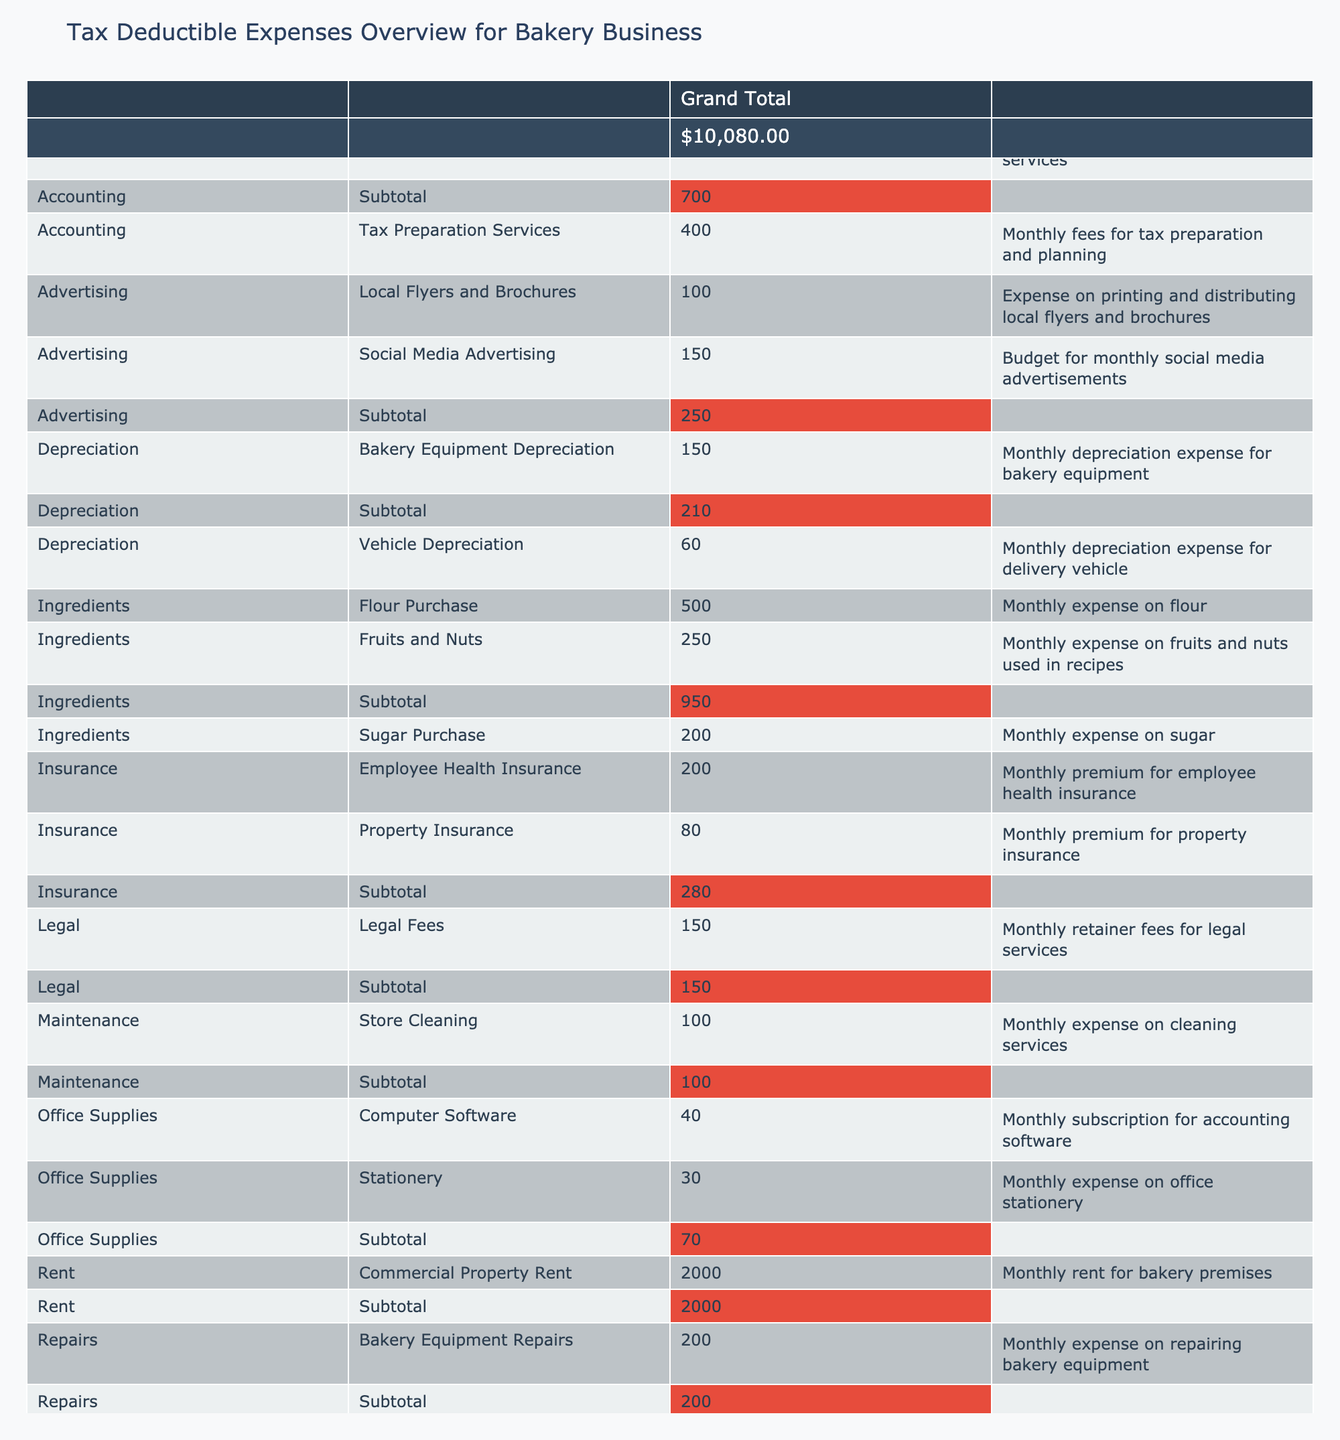What is the total amount spent on Utilities? The utilities expenditures in the table include Electricity Bill ($350), Water Bill ($50), and Gas Bill ($100). Adding these amounts gives a total of $350 + $50 + $100 = $500.
Answer: 500 What is the expense for Ingredients in total? The total expenses for Ingredients include Flour Purchase ($500), Sugar Purchase ($200), and Fruits and Nuts ($250). Summing these amounts: $500 + $200 + $250 gives a total of $950.
Answer: 950 Is the total amount spent on Salaries greater than the total amount spent on Insurance? The total Salaries expenses amount to Baker Salaries ($3000) plus Administrative Salaries ($1500), which equals $4500. The total Insurance expenses are Property Insurance ($80) plus Employee Health Insurance ($200), totaling $280. Since $4500 is greater than $280, the statement is true.
Answer: Yes What is the difference between the total amount spent on Advertising and the total amount dedicated to Repairs? The total Advertising expenses consist of Social Media Advertising ($150) and Local Flyers and Brochures ($100), totaling $250. The Repairs expense is solely Bakery Equipment Repairs ($200). The difference is $250 - $200, which equals $50.
Answer: 50 How much is spent on Depreciation for Bakery Equipment relative to Depreciation for Vehicle? The Depreciation for Bakery Equipment is $150 and for Vehicle Depreciation is $60. The relative amount spent can be calculated as $150 - $60 = $90.
Answer: 90 What is the average expense of Office Supplies? Office Supplies include Stationery ($30) and Computer Software ($40). The average is calculated as the sum ($30 + $40 = $70) divided by the number of items (2), resulting in $70 / 2 = $35.
Answer: 35 Which category has the highest single expense item? The highest single expense item is Baker Salaries at $3000 under the Salaries category. No other individual expense exceeds this value.
Answer: Salaries Is the total amount paid for Legal Fees more than the total for Travel Expenses? The total Legal Fees amount to $150, while the total Travel Expenses (Delivery Vehicle Fuel $120 and Travel Expenses for Ingredients $50) sum to $170. Since $150 is not greater than $170, the statement is false.
Answer: No What percentage of the total expenses is attributed to Store Cleaning? Store Cleaning expense is $100, and the total expenses amount to $10100 ($500 Total + $950 Total + $4500 Salaries + $280 Insurance + etc.). The percentage is calculated as ($100 / $10100) * 100, which gives approximately 0.99%.
Answer: 0.99% 